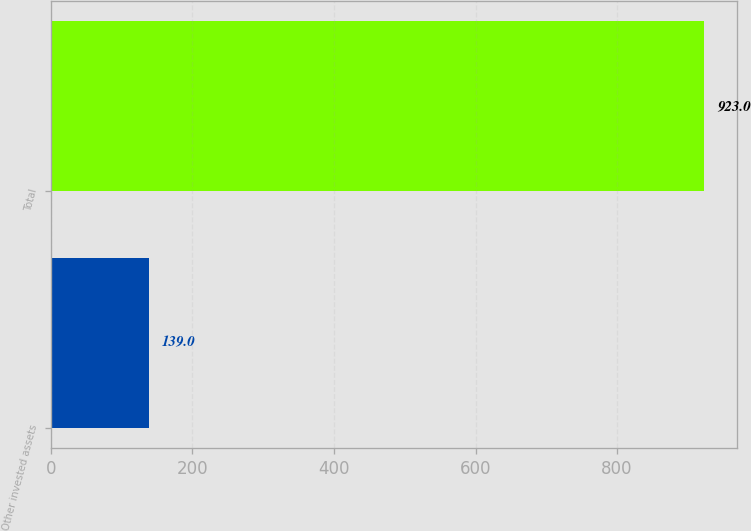<chart> <loc_0><loc_0><loc_500><loc_500><bar_chart><fcel>Other invested assets<fcel>Total<nl><fcel>139<fcel>923<nl></chart> 